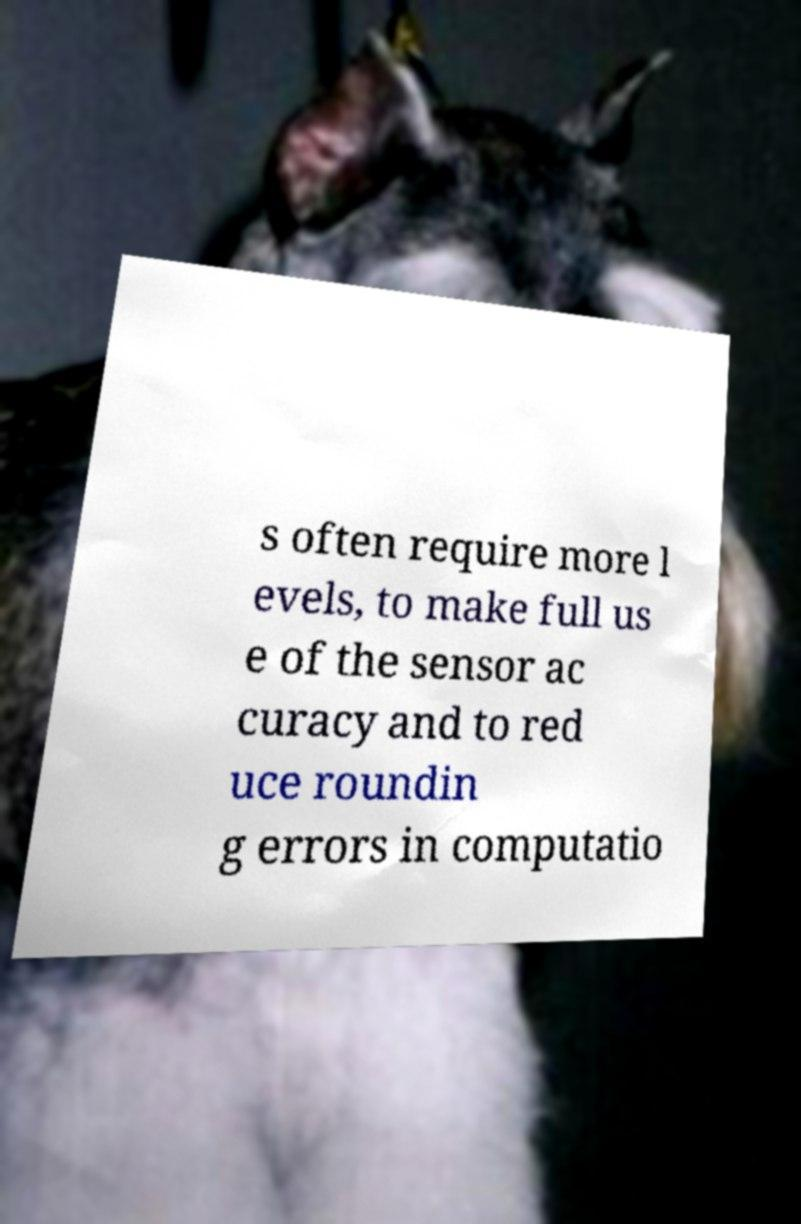Can you read and provide the text displayed in the image?This photo seems to have some interesting text. Can you extract and type it out for me? s often require more l evels, to make full us e of the sensor ac curacy and to red uce roundin g errors in computatio 